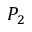<formula> <loc_0><loc_0><loc_500><loc_500>P _ { 2 }</formula> 